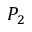<formula> <loc_0><loc_0><loc_500><loc_500>P _ { 2 }</formula> 